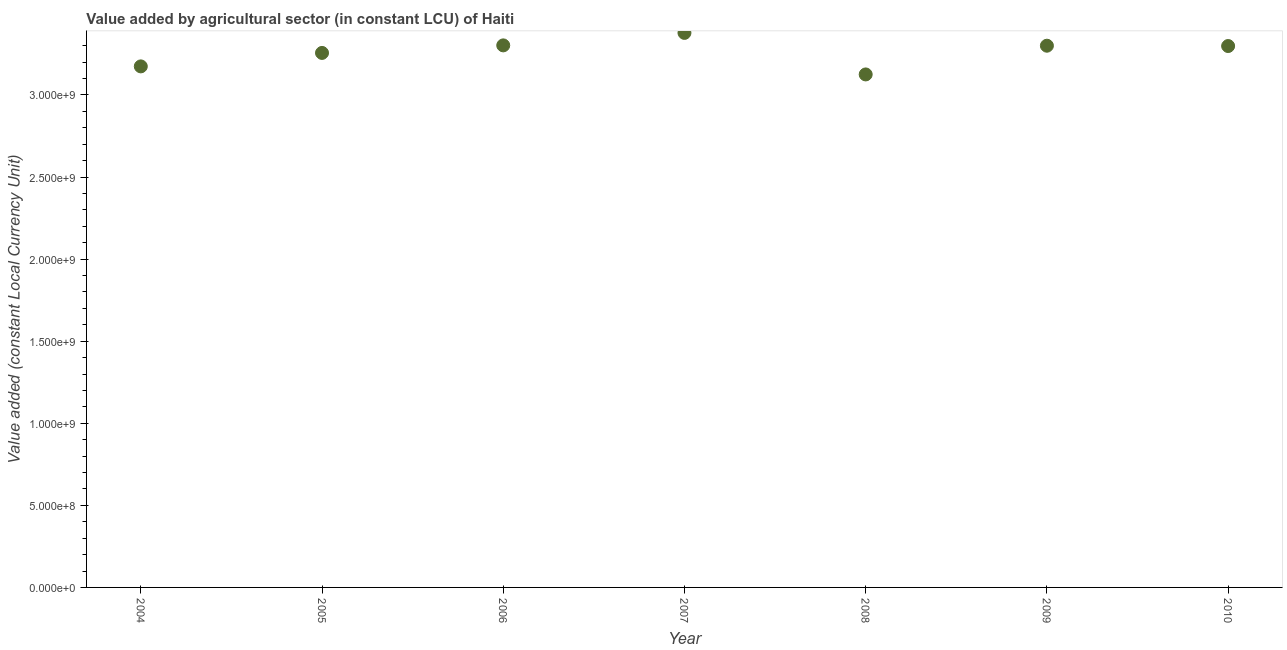What is the value added by agriculture sector in 2004?
Offer a very short reply. 3.17e+09. Across all years, what is the maximum value added by agriculture sector?
Keep it short and to the point. 3.38e+09. Across all years, what is the minimum value added by agriculture sector?
Keep it short and to the point. 3.12e+09. In which year was the value added by agriculture sector maximum?
Make the answer very short. 2007. In which year was the value added by agriculture sector minimum?
Ensure brevity in your answer.  2008. What is the sum of the value added by agriculture sector?
Provide a short and direct response. 2.28e+1. What is the difference between the value added by agriculture sector in 2005 and 2009?
Give a very brief answer. -4.40e+07. What is the average value added by agriculture sector per year?
Your answer should be very brief. 3.26e+09. What is the median value added by agriculture sector?
Give a very brief answer. 3.30e+09. In how many years, is the value added by agriculture sector greater than 1200000000 LCU?
Your answer should be compact. 7. What is the ratio of the value added by agriculture sector in 2009 to that in 2010?
Ensure brevity in your answer.  1. Is the difference between the value added by agriculture sector in 2005 and 2009 greater than the difference between any two years?
Provide a short and direct response. No. What is the difference between the highest and the second highest value added by agriculture sector?
Your answer should be compact. 7.60e+07. Is the sum of the value added by agriculture sector in 2004 and 2005 greater than the maximum value added by agriculture sector across all years?
Make the answer very short. Yes. What is the difference between the highest and the lowest value added by agriculture sector?
Offer a very short reply. 2.53e+08. Does the value added by agriculture sector monotonically increase over the years?
Your response must be concise. No. How many dotlines are there?
Provide a short and direct response. 1. How many years are there in the graph?
Your answer should be compact. 7. Are the values on the major ticks of Y-axis written in scientific E-notation?
Offer a very short reply. Yes. Does the graph contain grids?
Your response must be concise. No. What is the title of the graph?
Offer a terse response. Value added by agricultural sector (in constant LCU) of Haiti. What is the label or title of the Y-axis?
Offer a very short reply. Value added (constant Local Currency Unit). What is the Value added (constant Local Currency Unit) in 2004?
Keep it short and to the point. 3.17e+09. What is the Value added (constant Local Currency Unit) in 2005?
Provide a short and direct response. 3.26e+09. What is the Value added (constant Local Currency Unit) in 2006?
Provide a short and direct response. 3.30e+09. What is the Value added (constant Local Currency Unit) in 2007?
Provide a short and direct response. 3.38e+09. What is the Value added (constant Local Currency Unit) in 2008?
Provide a short and direct response. 3.12e+09. What is the Value added (constant Local Currency Unit) in 2009?
Make the answer very short. 3.30e+09. What is the Value added (constant Local Currency Unit) in 2010?
Your answer should be very brief. 3.30e+09. What is the difference between the Value added (constant Local Currency Unit) in 2004 and 2005?
Ensure brevity in your answer.  -8.20e+07. What is the difference between the Value added (constant Local Currency Unit) in 2004 and 2006?
Offer a very short reply. -1.28e+08. What is the difference between the Value added (constant Local Currency Unit) in 2004 and 2007?
Provide a succinct answer. -2.04e+08. What is the difference between the Value added (constant Local Currency Unit) in 2004 and 2008?
Make the answer very short. 4.90e+07. What is the difference between the Value added (constant Local Currency Unit) in 2004 and 2009?
Make the answer very short. -1.26e+08. What is the difference between the Value added (constant Local Currency Unit) in 2004 and 2010?
Ensure brevity in your answer.  -1.24e+08. What is the difference between the Value added (constant Local Currency Unit) in 2005 and 2006?
Provide a succinct answer. -4.60e+07. What is the difference between the Value added (constant Local Currency Unit) in 2005 and 2007?
Give a very brief answer. -1.22e+08. What is the difference between the Value added (constant Local Currency Unit) in 2005 and 2008?
Keep it short and to the point. 1.31e+08. What is the difference between the Value added (constant Local Currency Unit) in 2005 and 2009?
Your answer should be very brief. -4.40e+07. What is the difference between the Value added (constant Local Currency Unit) in 2005 and 2010?
Keep it short and to the point. -4.20e+07. What is the difference between the Value added (constant Local Currency Unit) in 2006 and 2007?
Your answer should be compact. -7.60e+07. What is the difference between the Value added (constant Local Currency Unit) in 2006 and 2008?
Offer a very short reply. 1.77e+08. What is the difference between the Value added (constant Local Currency Unit) in 2006 and 2010?
Offer a very short reply. 4.00e+06. What is the difference between the Value added (constant Local Currency Unit) in 2007 and 2008?
Keep it short and to the point. 2.53e+08. What is the difference between the Value added (constant Local Currency Unit) in 2007 and 2009?
Provide a short and direct response. 7.80e+07. What is the difference between the Value added (constant Local Currency Unit) in 2007 and 2010?
Give a very brief answer. 8.00e+07. What is the difference between the Value added (constant Local Currency Unit) in 2008 and 2009?
Your response must be concise. -1.75e+08. What is the difference between the Value added (constant Local Currency Unit) in 2008 and 2010?
Provide a succinct answer. -1.73e+08. What is the ratio of the Value added (constant Local Currency Unit) in 2004 to that in 2007?
Provide a short and direct response. 0.94. What is the ratio of the Value added (constant Local Currency Unit) in 2004 to that in 2009?
Your answer should be compact. 0.96. What is the ratio of the Value added (constant Local Currency Unit) in 2004 to that in 2010?
Make the answer very short. 0.96. What is the ratio of the Value added (constant Local Currency Unit) in 2005 to that in 2008?
Ensure brevity in your answer.  1.04. What is the ratio of the Value added (constant Local Currency Unit) in 2005 to that in 2010?
Your response must be concise. 0.99. What is the ratio of the Value added (constant Local Currency Unit) in 2006 to that in 2007?
Make the answer very short. 0.98. What is the ratio of the Value added (constant Local Currency Unit) in 2006 to that in 2008?
Your response must be concise. 1.06. What is the ratio of the Value added (constant Local Currency Unit) in 2006 to that in 2009?
Your answer should be compact. 1. What is the ratio of the Value added (constant Local Currency Unit) in 2006 to that in 2010?
Offer a terse response. 1. What is the ratio of the Value added (constant Local Currency Unit) in 2007 to that in 2008?
Make the answer very short. 1.08. What is the ratio of the Value added (constant Local Currency Unit) in 2008 to that in 2009?
Make the answer very short. 0.95. What is the ratio of the Value added (constant Local Currency Unit) in 2008 to that in 2010?
Your answer should be very brief. 0.95. What is the ratio of the Value added (constant Local Currency Unit) in 2009 to that in 2010?
Provide a short and direct response. 1. 